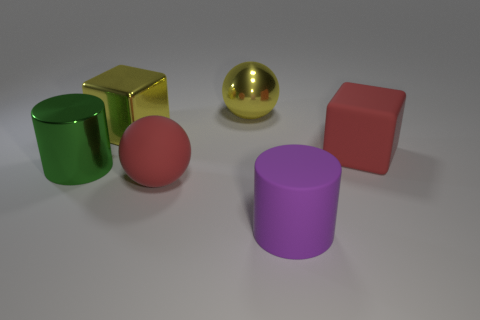How many objects are there and can you describe each one? There are five objects in the image. Starting from the left, there is a green cylinder, a golden cube, a shiny, reflective sphere that appears golden as well, a pink cube, and a purple cylinder. Which object stands out the most and why? The shiny, reflective sphere stands out the most because of its high gloss finish that reflects the light, making it appear luminous and drawing attention. 